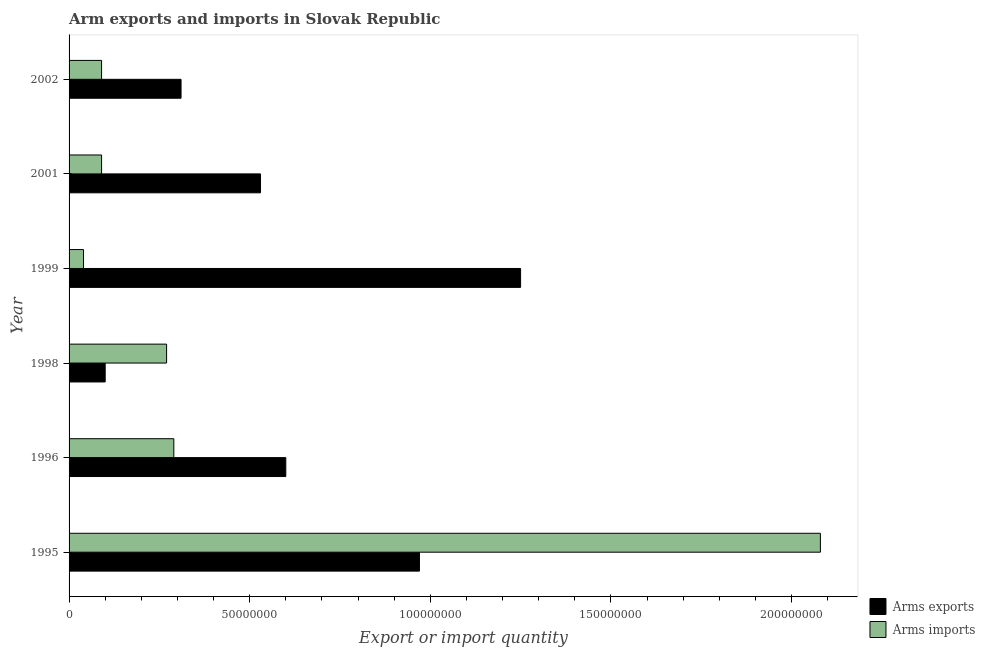How many groups of bars are there?
Keep it short and to the point. 6. Are the number of bars per tick equal to the number of legend labels?
Provide a short and direct response. Yes. Are the number of bars on each tick of the Y-axis equal?
Offer a very short reply. Yes. What is the label of the 2nd group of bars from the top?
Your answer should be compact. 2001. What is the arms exports in 1999?
Your answer should be compact. 1.25e+08. Across all years, what is the maximum arms imports?
Your answer should be compact. 2.08e+08. Across all years, what is the minimum arms exports?
Provide a succinct answer. 1.00e+07. What is the total arms exports in the graph?
Provide a short and direct response. 3.76e+08. What is the difference between the arms imports in 1998 and the arms exports in 1996?
Provide a succinct answer. -3.30e+07. What is the average arms imports per year?
Provide a succinct answer. 4.77e+07. In the year 1998, what is the difference between the arms exports and arms imports?
Give a very brief answer. -1.70e+07. In how many years, is the arms exports greater than 160000000 ?
Your answer should be compact. 0. What is the ratio of the arms exports in 1995 to that in 1996?
Make the answer very short. 1.62. Is the arms imports in 1995 less than that in 2002?
Make the answer very short. No. What is the difference between the highest and the second highest arms exports?
Make the answer very short. 2.80e+07. What is the difference between the highest and the lowest arms imports?
Provide a succinct answer. 2.04e+08. What does the 2nd bar from the top in 1998 represents?
Make the answer very short. Arms exports. What does the 1st bar from the bottom in 2001 represents?
Your response must be concise. Arms exports. Are all the bars in the graph horizontal?
Offer a very short reply. Yes. What is the difference between two consecutive major ticks on the X-axis?
Keep it short and to the point. 5.00e+07. Are the values on the major ticks of X-axis written in scientific E-notation?
Your answer should be very brief. No. Does the graph contain any zero values?
Offer a terse response. No. Does the graph contain grids?
Offer a very short reply. No. How many legend labels are there?
Provide a short and direct response. 2. What is the title of the graph?
Provide a short and direct response. Arm exports and imports in Slovak Republic. What is the label or title of the X-axis?
Keep it short and to the point. Export or import quantity. What is the Export or import quantity of Arms exports in 1995?
Offer a terse response. 9.70e+07. What is the Export or import quantity of Arms imports in 1995?
Offer a very short reply. 2.08e+08. What is the Export or import quantity in Arms exports in 1996?
Offer a terse response. 6.00e+07. What is the Export or import quantity in Arms imports in 1996?
Offer a terse response. 2.90e+07. What is the Export or import quantity in Arms exports in 1998?
Ensure brevity in your answer.  1.00e+07. What is the Export or import quantity in Arms imports in 1998?
Your answer should be compact. 2.70e+07. What is the Export or import quantity in Arms exports in 1999?
Your answer should be very brief. 1.25e+08. What is the Export or import quantity in Arms imports in 1999?
Make the answer very short. 4.00e+06. What is the Export or import quantity in Arms exports in 2001?
Offer a very short reply. 5.30e+07. What is the Export or import quantity of Arms imports in 2001?
Keep it short and to the point. 9.00e+06. What is the Export or import quantity of Arms exports in 2002?
Offer a terse response. 3.10e+07. What is the Export or import quantity in Arms imports in 2002?
Provide a short and direct response. 9.00e+06. Across all years, what is the maximum Export or import quantity in Arms exports?
Offer a terse response. 1.25e+08. Across all years, what is the maximum Export or import quantity of Arms imports?
Provide a short and direct response. 2.08e+08. What is the total Export or import quantity in Arms exports in the graph?
Provide a short and direct response. 3.76e+08. What is the total Export or import quantity in Arms imports in the graph?
Provide a succinct answer. 2.86e+08. What is the difference between the Export or import quantity in Arms exports in 1995 and that in 1996?
Ensure brevity in your answer.  3.70e+07. What is the difference between the Export or import quantity in Arms imports in 1995 and that in 1996?
Ensure brevity in your answer.  1.79e+08. What is the difference between the Export or import quantity in Arms exports in 1995 and that in 1998?
Make the answer very short. 8.70e+07. What is the difference between the Export or import quantity of Arms imports in 1995 and that in 1998?
Provide a short and direct response. 1.81e+08. What is the difference between the Export or import quantity in Arms exports in 1995 and that in 1999?
Provide a succinct answer. -2.80e+07. What is the difference between the Export or import quantity in Arms imports in 1995 and that in 1999?
Your response must be concise. 2.04e+08. What is the difference between the Export or import quantity in Arms exports in 1995 and that in 2001?
Your answer should be very brief. 4.40e+07. What is the difference between the Export or import quantity in Arms imports in 1995 and that in 2001?
Give a very brief answer. 1.99e+08. What is the difference between the Export or import quantity of Arms exports in 1995 and that in 2002?
Make the answer very short. 6.60e+07. What is the difference between the Export or import quantity in Arms imports in 1995 and that in 2002?
Keep it short and to the point. 1.99e+08. What is the difference between the Export or import quantity of Arms exports in 1996 and that in 1998?
Your answer should be compact. 5.00e+07. What is the difference between the Export or import quantity in Arms imports in 1996 and that in 1998?
Your response must be concise. 2.00e+06. What is the difference between the Export or import quantity in Arms exports in 1996 and that in 1999?
Provide a short and direct response. -6.50e+07. What is the difference between the Export or import quantity in Arms imports in 1996 and that in 1999?
Ensure brevity in your answer.  2.50e+07. What is the difference between the Export or import quantity of Arms exports in 1996 and that in 2001?
Offer a very short reply. 7.00e+06. What is the difference between the Export or import quantity in Arms imports in 1996 and that in 2001?
Your response must be concise. 2.00e+07. What is the difference between the Export or import quantity of Arms exports in 1996 and that in 2002?
Give a very brief answer. 2.90e+07. What is the difference between the Export or import quantity in Arms exports in 1998 and that in 1999?
Keep it short and to the point. -1.15e+08. What is the difference between the Export or import quantity of Arms imports in 1998 and that in 1999?
Provide a succinct answer. 2.30e+07. What is the difference between the Export or import quantity of Arms exports in 1998 and that in 2001?
Make the answer very short. -4.30e+07. What is the difference between the Export or import quantity in Arms imports in 1998 and that in 2001?
Give a very brief answer. 1.80e+07. What is the difference between the Export or import quantity of Arms exports in 1998 and that in 2002?
Your response must be concise. -2.10e+07. What is the difference between the Export or import quantity of Arms imports in 1998 and that in 2002?
Your answer should be very brief. 1.80e+07. What is the difference between the Export or import quantity of Arms exports in 1999 and that in 2001?
Offer a terse response. 7.20e+07. What is the difference between the Export or import quantity in Arms imports in 1999 and that in 2001?
Give a very brief answer. -5.00e+06. What is the difference between the Export or import quantity in Arms exports in 1999 and that in 2002?
Give a very brief answer. 9.40e+07. What is the difference between the Export or import quantity of Arms imports in 1999 and that in 2002?
Keep it short and to the point. -5.00e+06. What is the difference between the Export or import quantity of Arms exports in 2001 and that in 2002?
Offer a very short reply. 2.20e+07. What is the difference between the Export or import quantity of Arms exports in 1995 and the Export or import quantity of Arms imports in 1996?
Offer a very short reply. 6.80e+07. What is the difference between the Export or import quantity in Arms exports in 1995 and the Export or import quantity in Arms imports in 1998?
Your answer should be compact. 7.00e+07. What is the difference between the Export or import quantity of Arms exports in 1995 and the Export or import quantity of Arms imports in 1999?
Your answer should be compact. 9.30e+07. What is the difference between the Export or import quantity in Arms exports in 1995 and the Export or import quantity in Arms imports in 2001?
Offer a terse response. 8.80e+07. What is the difference between the Export or import quantity in Arms exports in 1995 and the Export or import quantity in Arms imports in 2002?
Provide a short and direct response. 8.80e+07. What is the difference between the Export or import quantity in Arms exports in 1996 and the Export or import quantity in Arms imports in 1998?
Ensure brevity in your answer.  3.30e+07. What is the difference between the Export or import quantity of Arms exports in 1996 and the Export or import quantity of Arms imports in 1999?
Provide a short and direct response. 5.60e+07. What is the difference between the Export or import quantity in Arms exports in 1996 and the Export or import quantity in Arms imports in 2001?
Offer a very short reply. 5.10e+07. What is the difference between the Export or import quantity in Arms exports in 1996 and the Export or import quantity in Arms imports in 2002?
Make the answer very short. 5.10e+07. What is the difference between the Export or import quantity of Arms exports in 1998 and the Export or import quantity of Arms imports in 1999?
Keep it short and to the point. 6.00e+06. What is the difference between the Export or import quantity in Arms exports in 1999 and the Export or import quantity in Arms imports in 2001?
Offer a terse response. 1.16e+08. What is the difference between the Export or import quantity of Arms exports in 1999 and the Export or import quantity of Arms imports in 2002?
Offer a terse response. 1.16e+08. What is the difference between the Export or import quantity in Arms exports in 2001 and the Export or import quantity in Arms imports in 2002?
Offer a very short reply. 4.40e+07. What is the average Export or import quantity of Arms exports per year?
Keep it short and to the point. 6.27e+07. What is the average Export or import quantity of Arms imports per year?
Your response must be concise. 4.77e+07. In the year 1995, what is the difference between the Export or import quantity in Arms exports and Export or import quantity in Arms imports?
Your response must be concise. -1.11e+08. In the year 1996, what is the difference between the Export or import quantity of Arms exports and Export or import quantity of Arms imports?
Your response must be concise. 3.10e+07. In the year 1998, what is the difference between the Export or import quantity of Arms exports and Export or import quantity of Arms imports?
Offer a very short reply. -1.70e+07. In the year 1999, what is the difference between the Export or import quantity of Arms exports and Export or import quantity of Arms imports?
Your answer should be compact. 1.21e+08. In the year 2001, what is the difference between the Export or import quantity in Arms exports and Export or import quantity in Arms imports?
Provide a short and direct response. 4.40e+07. In the year 2002, what is the difference between the Export or import quantity in Arms exports and Export or import quantity in Arms imports?
Offer a very short reply. 2.20e+07. What is the ratio of the Export or import quantity of Arms exports in 1995 to that in 1996?
Keep it short and to the point. 1.62. What is the ratio of the Export or import quantity of Arms imports in 1995 to that in 1996?
Provide a succinct answer. 7.17. What is the ratio of the Export or import quantity of Arms exports in 1995 to that in 1998?
Make the answer very short. 9.7. What is the ratio of the Export or import quantity of Arms imports in 1995 to that in 1998?
Your answer should be very brief. 7.7. What is the ratio of the Export or import quantity of Arms exports in 1995 to that in 1999?
Give a very brief answer. 0.78. What is the ratio of the Export or import quantity in Arms imports in 1995 to that in 1999?
Keep it short and to the point. 52. What is the ratio of the Export or import quantity of Arms exports in 1995 to that in 2001?
Make the answer very short. 1.83. What is the ratio of the Export or import quantity of Arms imports in 1995 to that in 2001?
Ensure brevity in your answer.  23.11. What is the ratio of the Export or import quantity in Arms exports in 1995 to that in 2002?
Offer a very short reply. 3.13. What is the ratio of the Export or import quantity of Arms imports in 1995 to that in 2002?
Ensure brevity in your answer.  23.11. What is the ratio of the Export or import quantity of Arms exports in 1996 to that in 1998?
Provide a short and direct response. 6. What is the ratio of the Export or import quantity in Arms imports in 1996 to that in 1998?
Your answer should be very brief. 1.07. What is the ratio of the Export or import quantity of Arms exports in 1996 to that in 1999?
Provide a short and direct response. 0.48. What is the ratio of the Export or import quantity of Arms imports in 1996 to that in 1999?
Provide a succinct answer. 7.25. What is the ratio of the Export or import quantity of Arms exports in 1996 to that in 2001?
Offer a terse response. 1.13. What is the ratio of the Export or import quantity of Arms imports in 1996 to that in 2001?
Give a very brief answer. 3.22. What is the ratio of the Export or import quantity in Arms exports in 1996 to that in 2002?
Your response must be concise. 1.94. What is the ratio of the Export or import quantity in Arms imports in 1996 to that in 2002?
Your answer should be compact. 3.22. What is the ratio of the Export or import quantity of Arms exports in 1998 to that in 1999?
Ensure brevity in your answer.  0.08. What is the ratio of the Export or import quantity in Arms imports in 1998 to that in 1999?
Provide a short and direct response. 6.75. What is the ratio of the Export or import quantity in Arms exports in 1998 to that in 2001?
Your answer should be compact. 0.19. What is the ratio of the Export or import quantity in Arms imports in 1998 to that in 2001?
Give a very brief answer. 3. What is the ratio of the Export or import quantity in Arms exports in 1998 to that in 2002?
Provide a succinct answer. 0.32. What is the ratio of the Export or import quantity in Arms imports in 1998 to that in 2002?
Your answer should be very brief. 3. What is the ratio of the Export or import quantity of Arms exports in 1999 to that in 2001?
Your response must be concise. 2.36. What is the ratio of the Export or import quantity of Arms imports in 1999 to that in 2001?
Ensure brevity in your answer.  0.44. What is the ratio of the Export or import quantity of Arms exports in 1999 to that in 2002?
Make the answer very short. 4.03. What is the ratio of the Export or import quantity of Arms imports in 1999 to that in 2002?
Make the answer very short. 0.44. What is the ratio of the Export or import quantity of Arms exports in 2001 to that in 2002?
Provide a short and direct response. 1.71. What is the ratio of the Export or import quantity in Arms imports in 2001 to that in 2002?
Offer a very short reply. 1. What is the difference between the highest and the second highest Export or import quantity of Arms exports?
Your answer should be compact. 2.80e+07. What is the difference between the highest and the second highest Export or import quantity of Arms imports?
Ensure brevity in your answer.  1.79e+08. What is the difference between the highest and the lowest Export or import quantity in Arms exports?
Ensure brevity in your answer.  1.15e+08. What is the difference between the highest and the lowest Export or import quantity of Arms imports?
Your answer should be compact. 2.04e+08. 